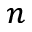Convert formula to latex. <formula><loc_0><loc_0><loc_500><loc_500>_ { n }</formula> 